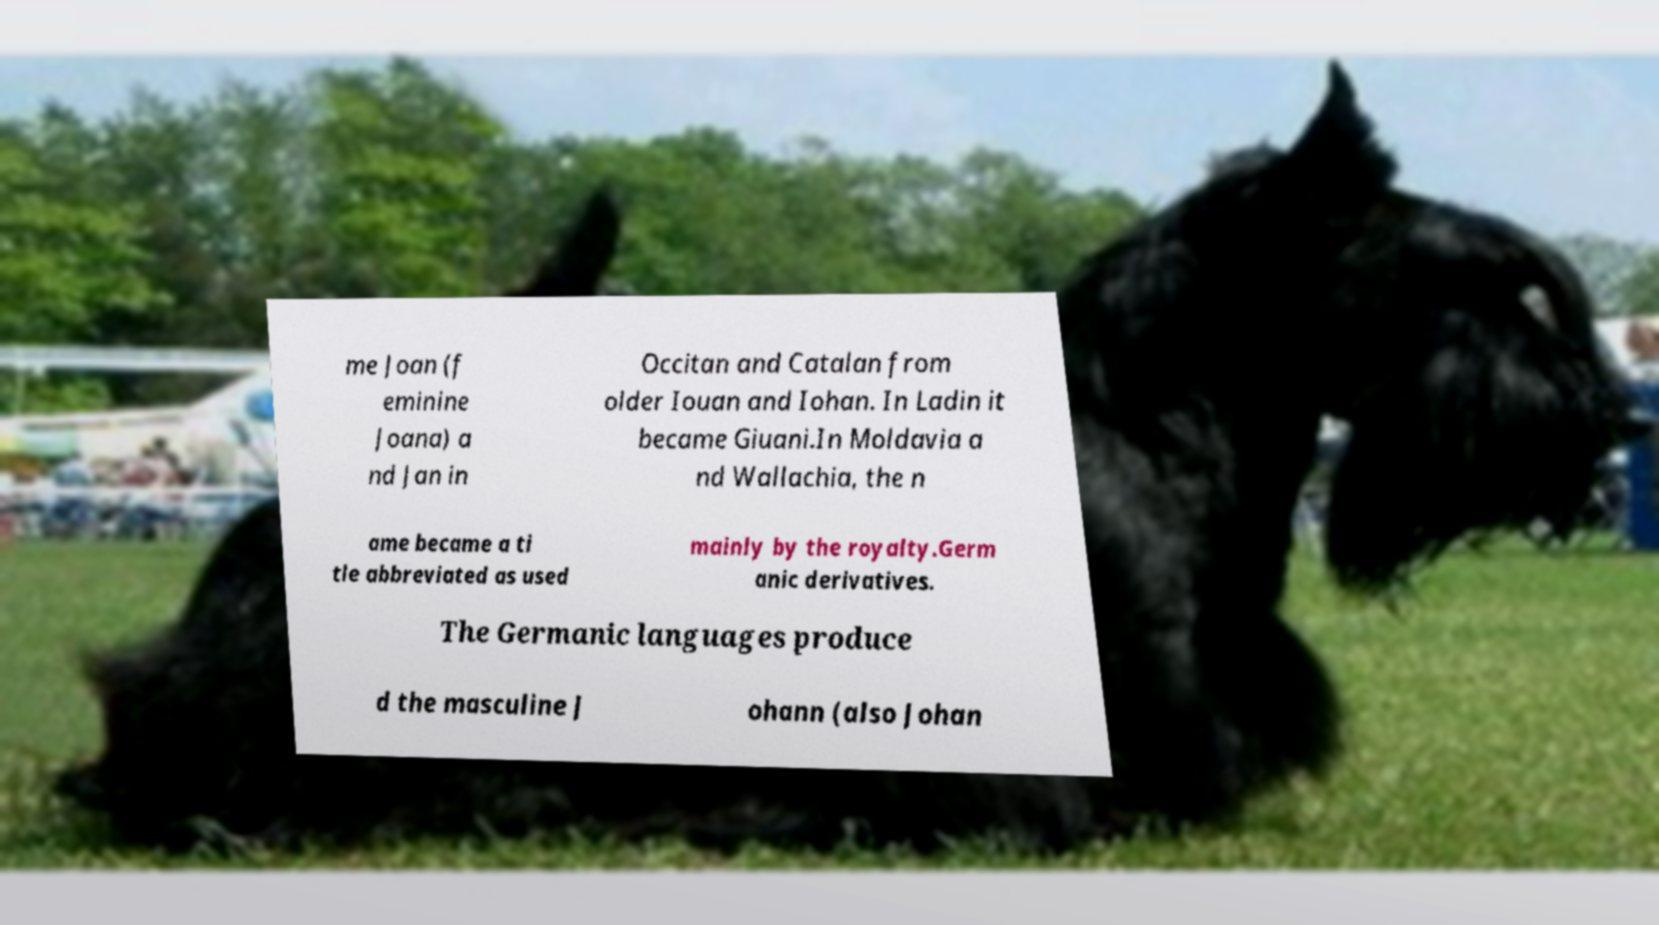Could you assist in decoding the text presented in this image and type it out clearly? me Joan (f eminine Joana) a nd Jan in Occitan and Catalan from older Iouan and Iohan. In Ladin it became Giuani.In Moldavia a nd Wallachia, the n ame became a ti tle abbreviated as used mainly by the royalty.Germ anic derivatives. The Germanic languages produce d the masculine J ohann (also Johan 